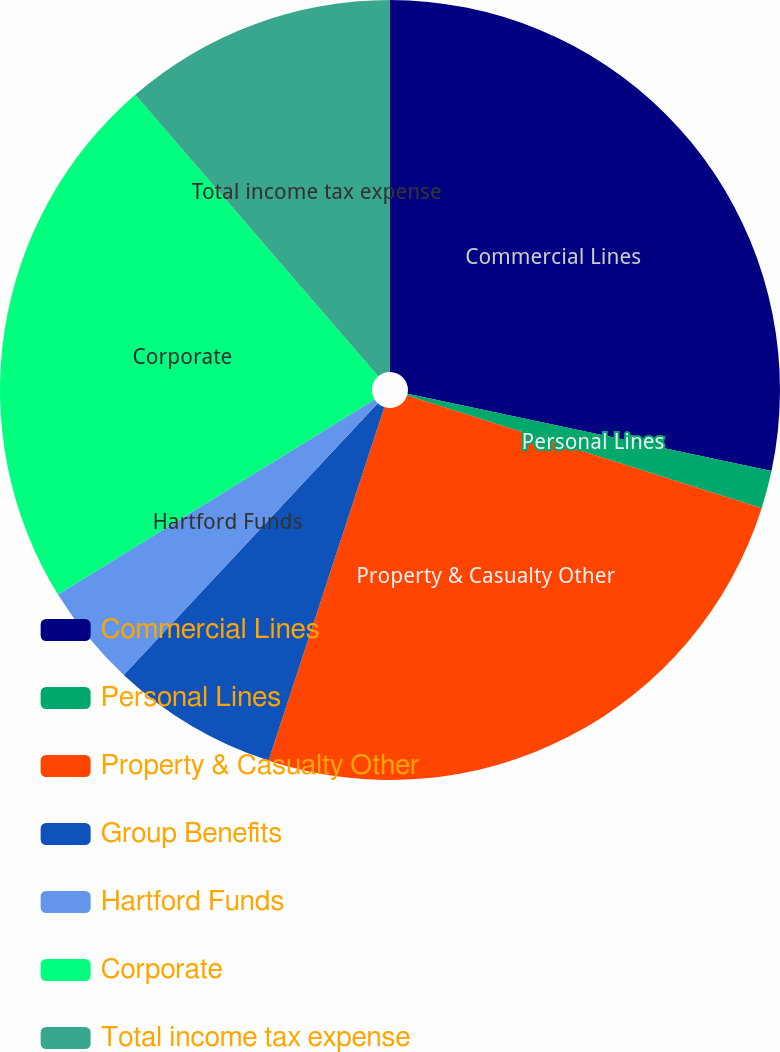Convert chart to OTSL. <chart><loc_0><loc_0><loc_500><loc_500><pie_chart><fcel>Commercial Lines<fcel>Personal Lines<fcel>Property & Casualty Other<fcel>Group Benefits<fcel>Hartford Funds<fcel>Corporate<fcel>Total income tax expense<nl><fcel>28.33%<fcel>1.57%<fcel>25.14%<fcel>6.92%<fcel>4.25%<fcel>22.46%<fcel>11.33%<nl></chart> 